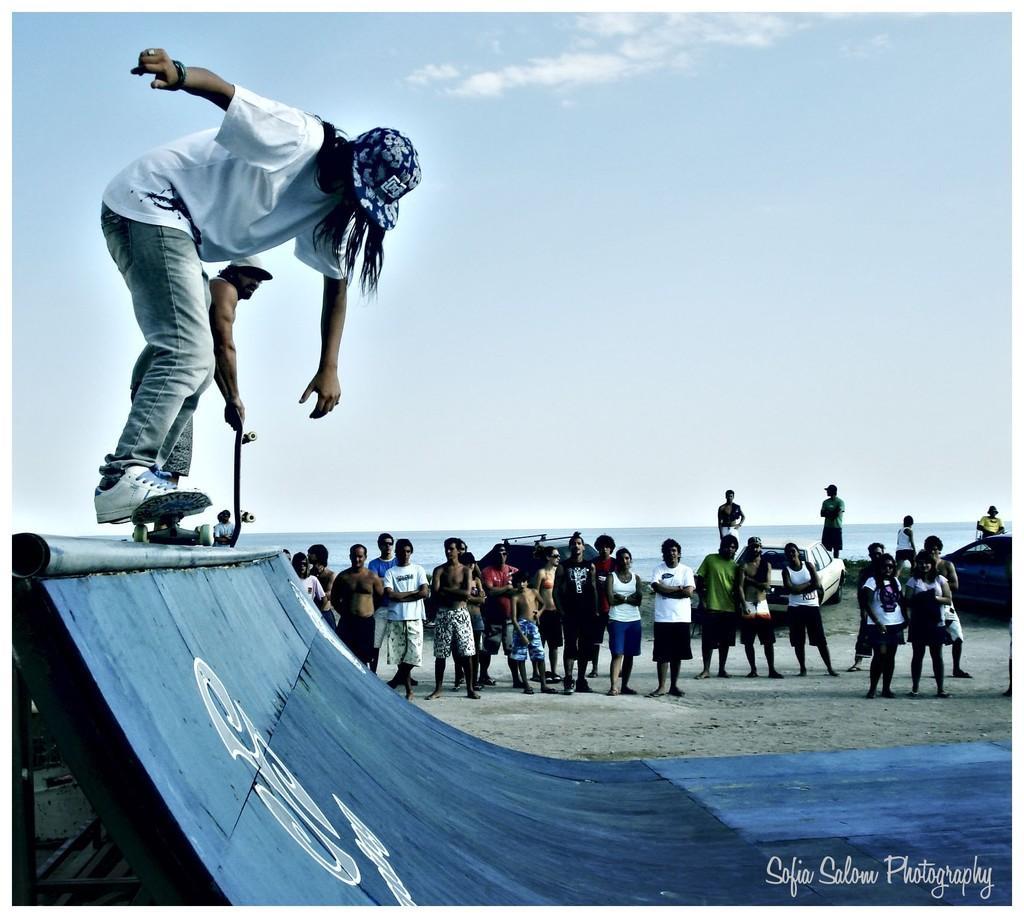Describe this image in one or two sentences. In this image on the left, there is a man, he wears a t shirt, trouser, shoes and cap, he is skating and there is a man. At the bottom there is skating rink and text. In the background there are many people, sand, vehicle, water, sky and clouds. 